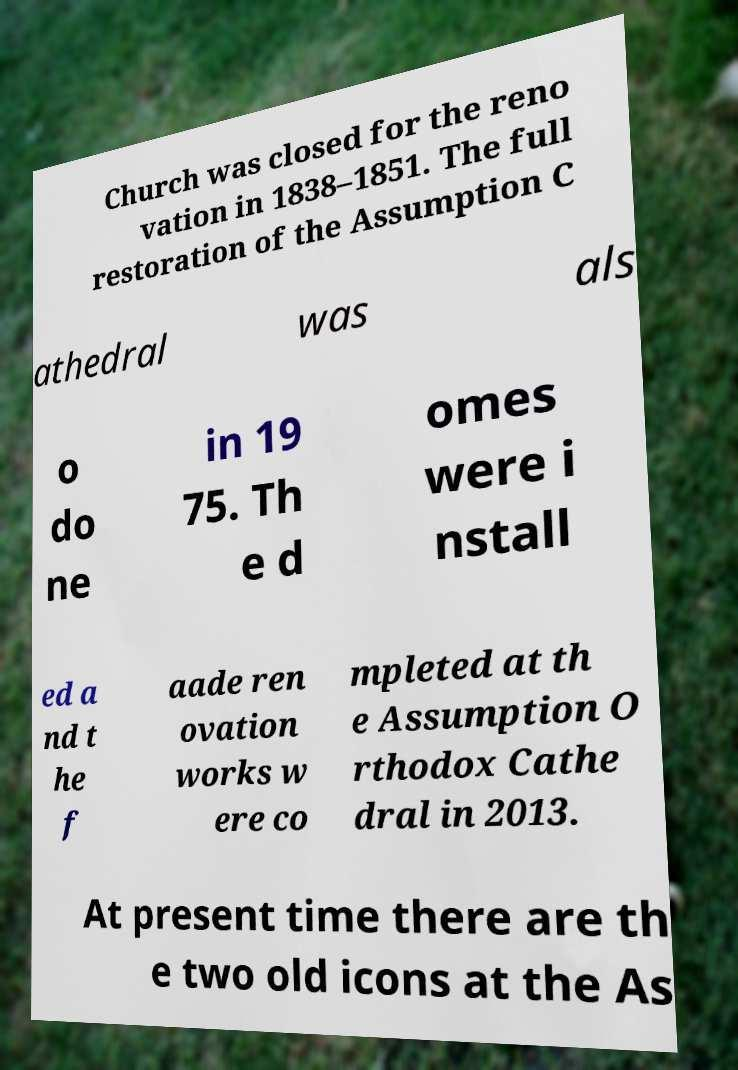I need the written content from this picture converted into text. Can you do that? Church was closed for the reno vation in 1838–1851. The full restoration of the Assumption C athedral was als o do ne in 19 75. Th e d omes were i nstall ed a nd t he f aade ren ovation works w ere co mpleted at th e Assumption O rthodox Cathe dral in 2013. At present time there are th e two old icons at the As 